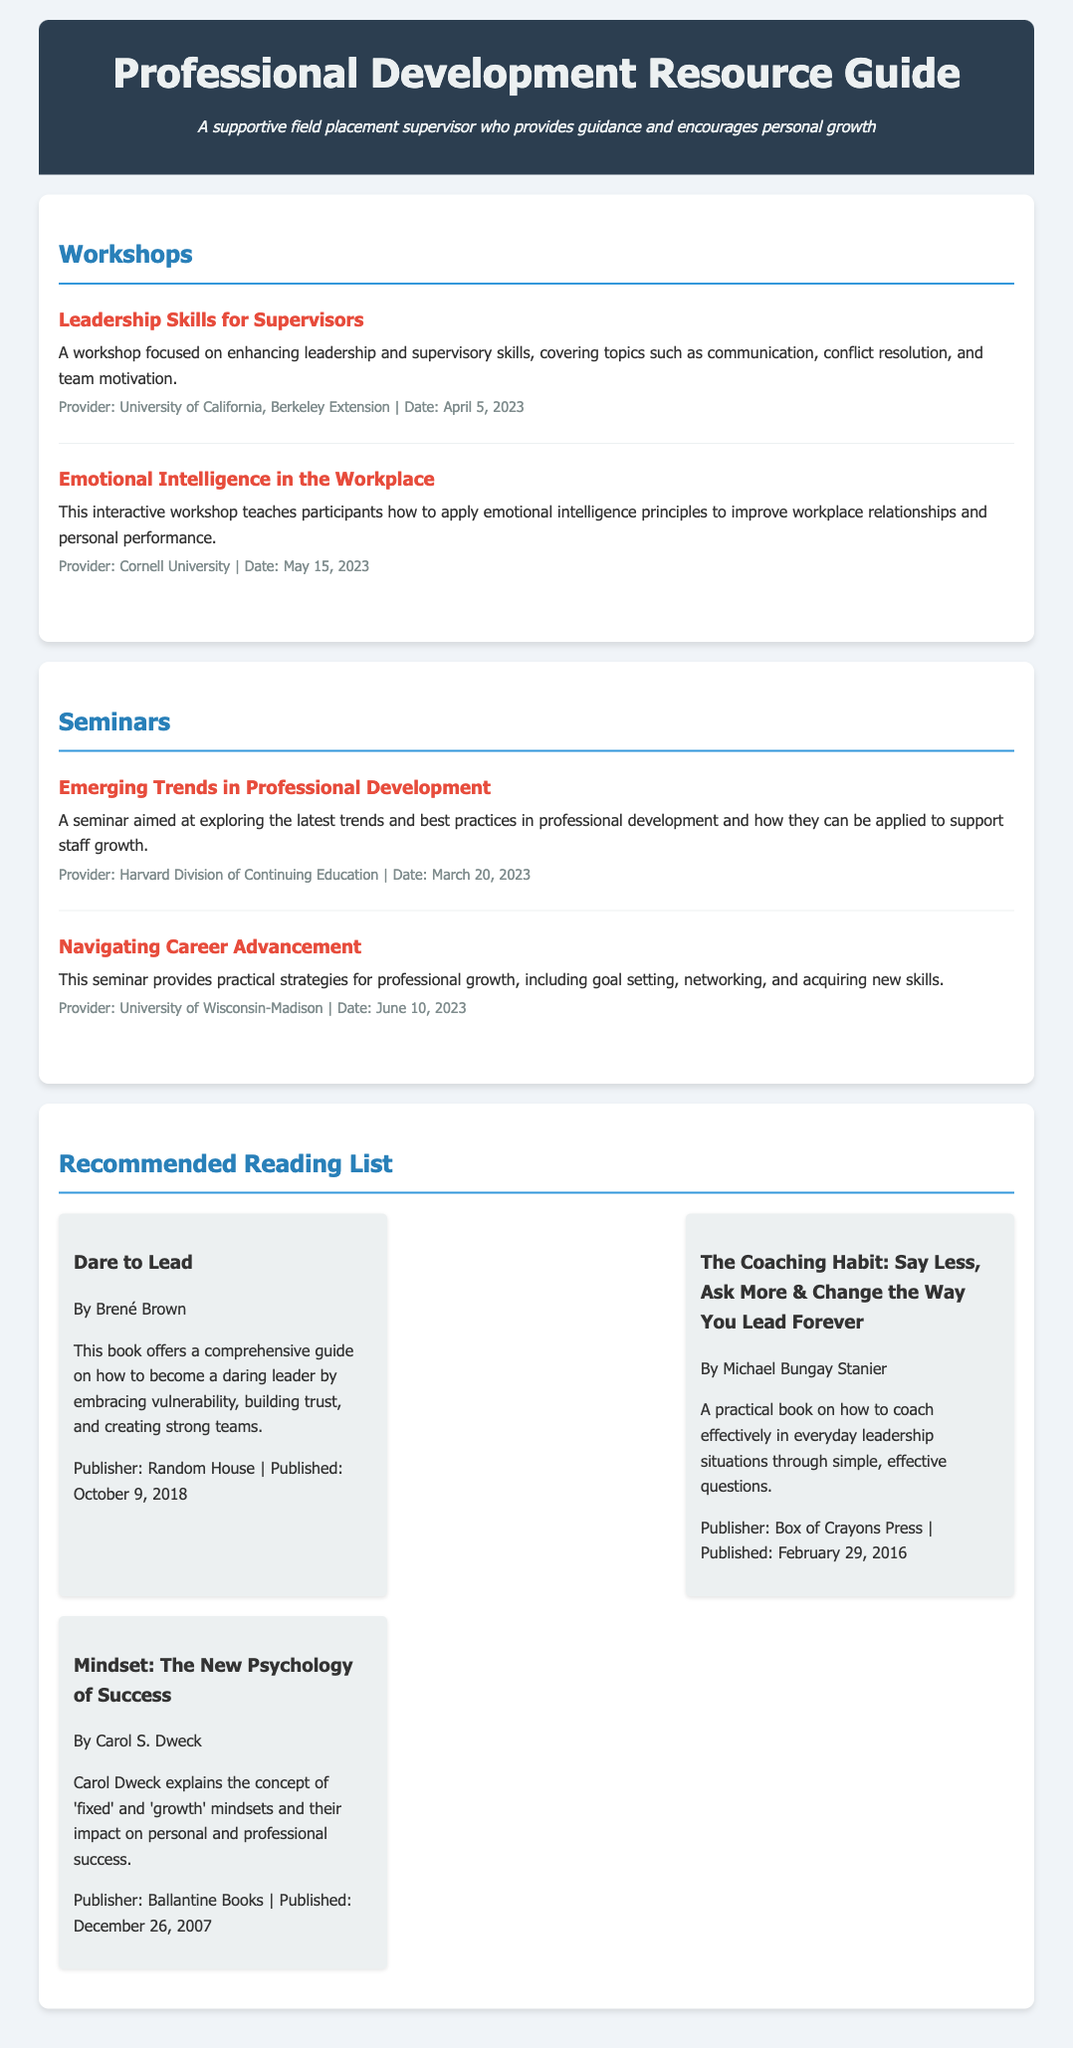What workshop focuses on enhancing leadership skills? The document lists "Leadership Skills for Supervisors" as a workshop dedicated to enhancing leadership skills.
Answer: Leadership Skills for Supervisors Who is the provider for the seminar on navigating career advancement? The provider for the seminar titled "Navigating Career Advancement" is mentioned in the document as the University of Wisconsin-Madison.
Answer: University of Wisconsin-Madison What date is the emotional intelligence workshop scheduled? The date for the "Emotional Intelligence in the Workplace" workshop is clearly stated in the document as May 15, 2023.
Answer: May 15, 2023 Which book is written by Brené Brown? The document specifies "Dare to Lead" as the book authored by Brené Brown.
Answer: Dare to Lead How many workshops are listed in the document? The document enumerates two workshops, indicating a specific count for that section.
Answer: 2 What is the main theme of the seminar on emerging trends? It is mentioned in the document that the seminar focuses on exploring the latest trends in professional development.
Answer: Latest trends in professional development Identify the publisher of "Mindset: The New Psychology of Success". The document states that "Mindset: The New Psychology of Success" is published by Ballantine Books.
Answer: Ballantine Books What is the publication date of "The Coaching Habit"? The document indicates that "The Coaching Habit" was published on February 29, 2016.
Answer: February 29, 2016 